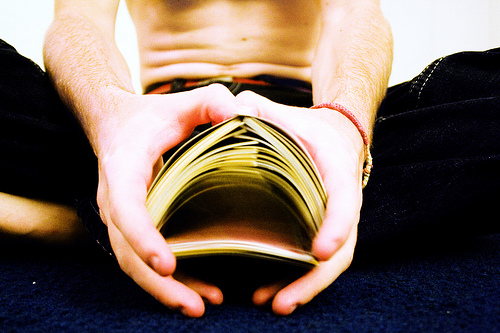<image>
Is there a man above the cards? Yes. The man is positioned above the cards in the vertical space, higher up in the scene. 